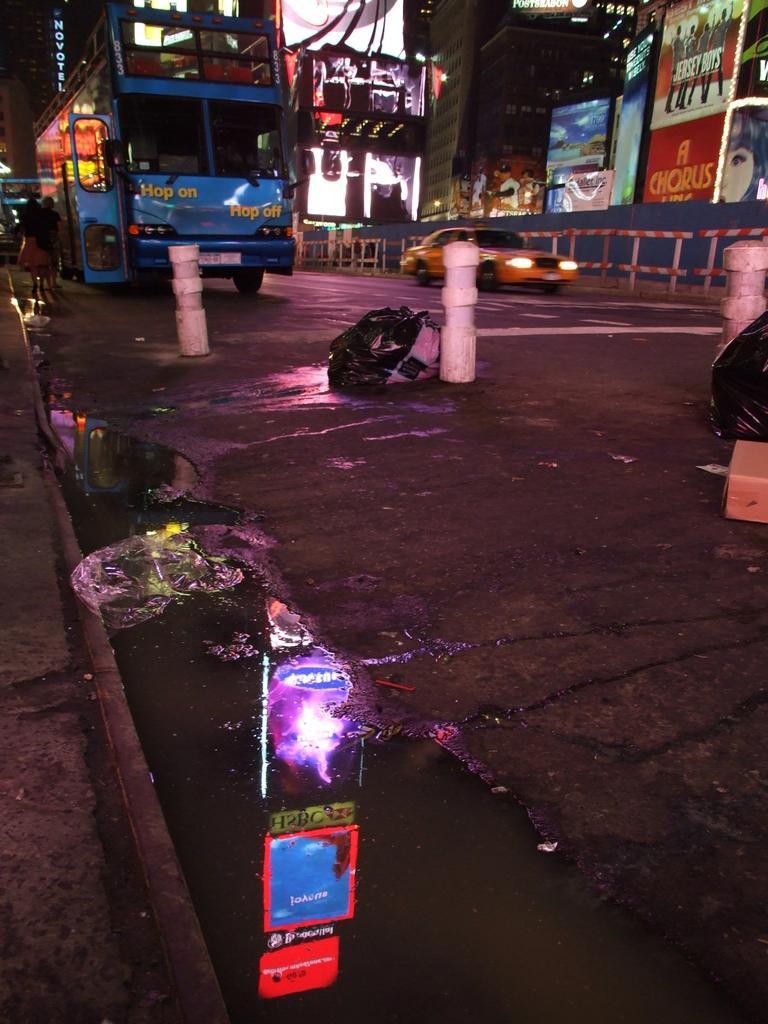How would you summarize this image in a sentence or two? In this image there is a road, on that road there are vehicles and poles, in the background there are shops. 